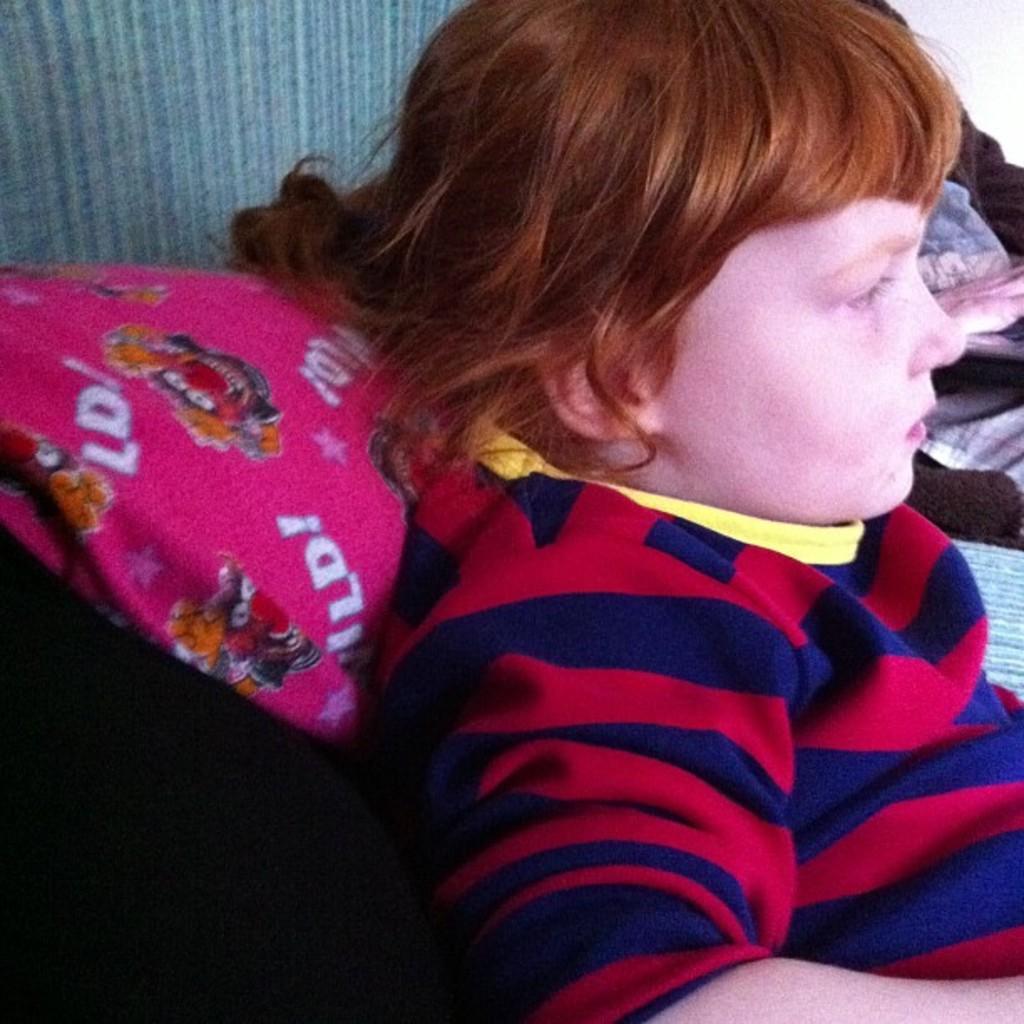How would you summarize this image in a sentence or two? In the picture there is a kid laying on some tool,there is a pink pillow behind the kid's neck,the kid is wearing red and blue shirt. 